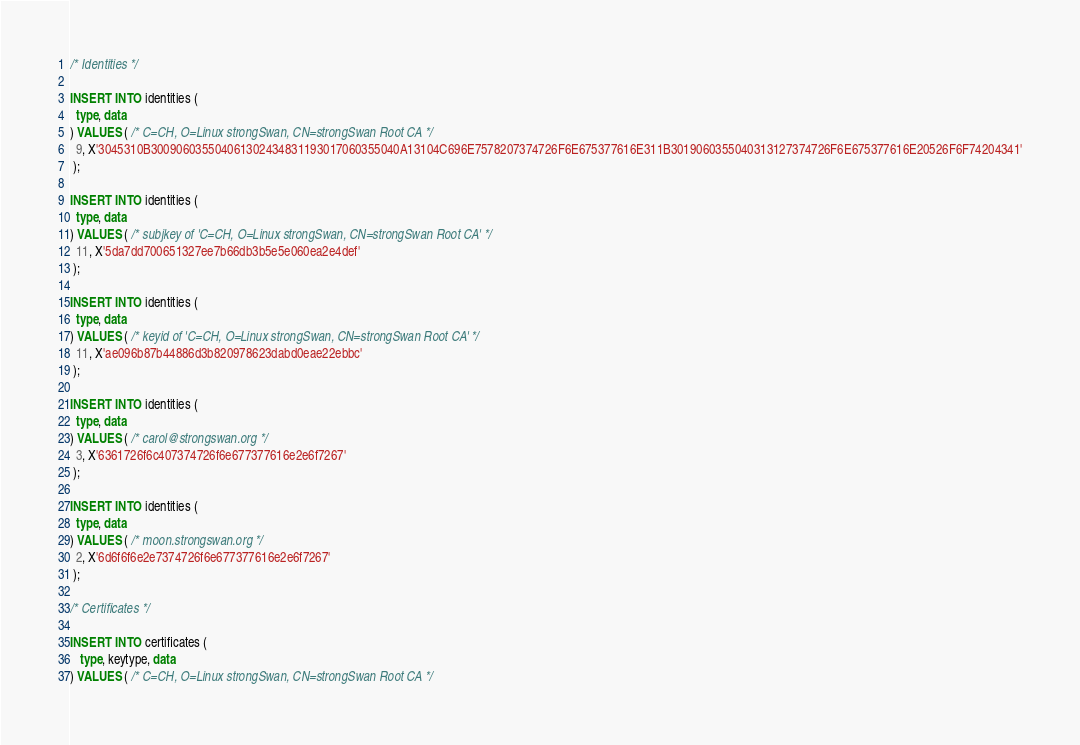<code> <loc_0><loc_0><loc_500><loc_500><_SQL_>/* Identities */

INSERT INTO identities (
  type, data
) VALUES ( /* C=CH, O=Linux strongSwan, CN=strongSwan Root CA */
  9, X'3045310B300906035504061302434831193017060355040A13104C696E7578207374726F6E675377616E311B3019060355040313127374726F6E675377616E20526F6F74204341'
 );

INSERT INTO identities (
  type, data
) VALUES ( /* subjkey of 'C=CH, O=Linux strongSwan, CN=strongSwan Root CA' */
  11, X'5da7dd700651327ee7b66db3b5e5e060ea2e4def'
 );

INSERT INTO identities (
  type, data
) VALUES ( /* keyid of 'C=CH, O=Linux strongSwan, CN=strongSwan Root CA' */
  11, X'ae096b87b44886d3b820978623dabd0eae22ebbc'
 );

INSERT INTO identities (
  type, data
) VALUES ( /* carol@strongswan.org */
  3, X'6361726f6c407374726f6e677377616e2e6f7267'
 );

INSERT INTO identities (
  type, data
) VALUES ( /* moon.strongswan.org */
  2, X'6d6f6f6e2e7374726f6e677377616e2e6f7267'
 );

/* Certificates */

INSERT INTO certificates (
   type, keytype, data
) VALUES ( /* C=CH, O=Linux strongSwan, CN=strongSwan Root CA */</code> 